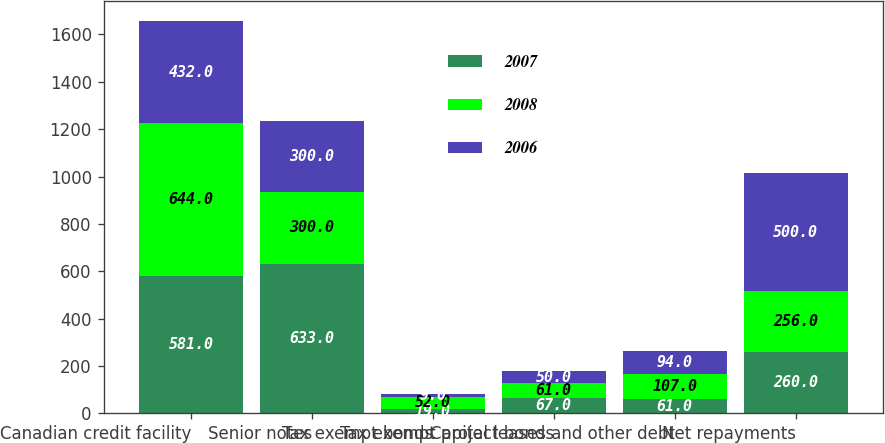Convert chart. <chart><loc_0><loc_0><loc_500><loc_500><stacked_bar_chart><ecel><fcel>Canadian credit facility<fcel>Senior notes<fcel>Tax exempt bonds<fcel>Tax exempt project bonds<fcel>Capital leases and other debt<fcel>Net repayments<nl><fcel>2007<fcel>581<fcel>633<fcel>19<fcel>67<fcel>61<fcel>260<nl><fcel>2008<fcel>644<fcel>300<fcel>52<fcel>61<fcel>107<fcel>256<nl><fcel>2006<fcel>432<fcel>300<fcel>9<fcel>50<fcel>94<fcel>500<nl></chart> 